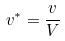Convert formula to latex. <formula><loc_0><loc_0><loc_500><loc_500>v ^ { * } = \frac { v } { V }</formula> 